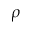<formula> <loc_0><loc_0><loc_500><loc_500>\rho</formula> 